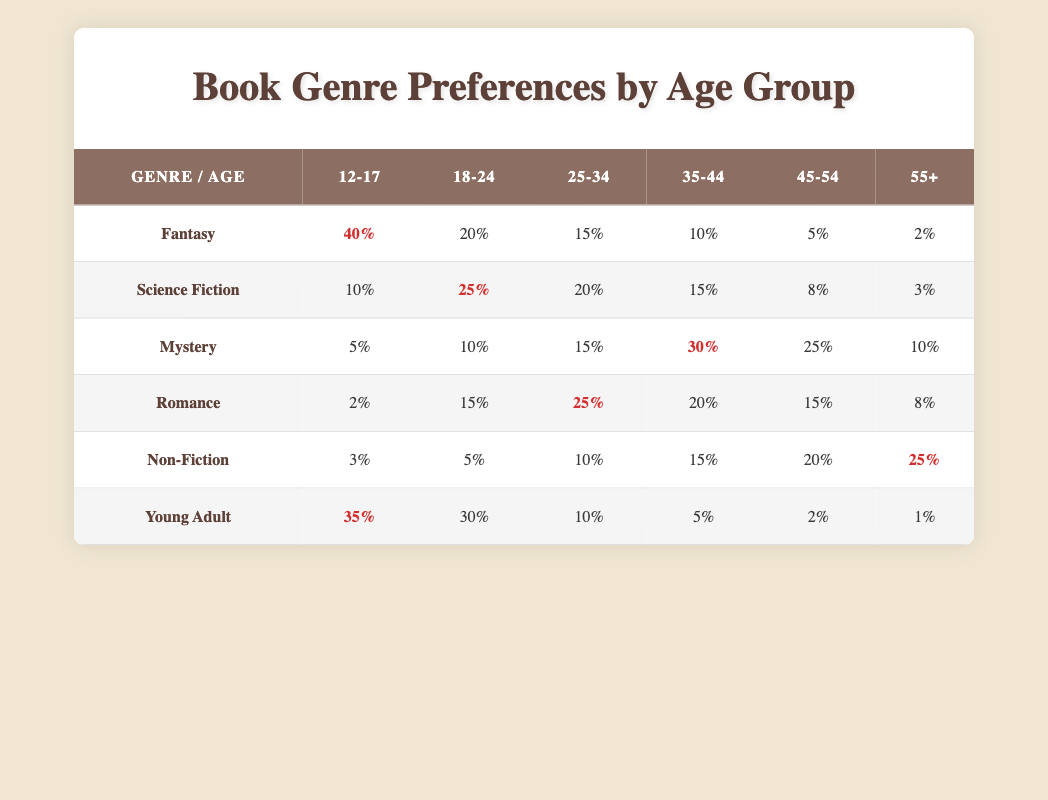What percentage of 35-44 year-olds prefer Mystery? According to the table, 30% of the 35-44 age group prefer the Mystery genre. This is shown explicitly in the data corresponding to that age group and genre.
Answer: 30% Which age group has the highest preference for Fantasy? The table shows that the 12-17 age group has the highest preference for Fantasy, at 40%. This can be directly observed in the row for Fantasy under the 12-17 column.
Answer: 12-17 What is the combined percentage of Science Fiction and Romance preferences among 25-34 year-olds? From the table, the percentage for Science Fiction in the 25-34 age group is 20%, and for Romance, it is 25%. Adding these together: 20% + 25% = 45%.
Answer: 45% Is the preference for Non-Fiction higher among older adults (aged 45-54 and 55+) compared to younger adults (aged 12-17 and 18-24)? For Non-Fiction, the percentages for 45-54 and 55+ are 20% and 25%, respectively, totaling 45%. Meanwhile, for 12-17 and 18-24, the percentages are 3% and 5%, totaling 8%. Thus, 45% is higher than 8%.
Answer: Yes What genre is most preferred by the 18-24 age group overall? Analyzing the percentages for each genre for the 18-24 age group shows Science Fiction is the most preferred at 25%, followed by Romance at 15%, Fantasy at 20%, and others lower. Therefore, Science Fiction is the top genre.
Answer: Science Fiction Which age groups have more than 20% preference for Young Adult books? The table shows that both the 12-17 age group (35%) and the 18-24 age group (30%) have more than 20% preference for Young Adult books, while the other groups do not exceed this percentage.
Answer: 12-17 and 18-24 If you were to rank the genres based on the preference of the 45-54 age group, which would be in the top three? The percentages for the 45-54 age group show Mystery at 25%, Non-Fiction at 20%, and Romance at 15%. Therefore, the top three genres for this age group are Mystery, Non-Fiction, and Romance.
Answer: Mystery, Non-Fiction, Romance What is the difference in preference between Fantasy and Young Adult books for the 12-17 age group? For the 12-17 age group, Fantasy is preferred at 40% and Young Adult at 35%. The difference is calculated as 40% - 35% = 5%.
Answer: 5% Which genre has the least preference from the 55+ age group? Reviewing the 55+ age group in the table, Fantasy has the least preference at 2%. This is the lowest percentage in that row for the genre preferences of that age group.
Answer: Fantasy 